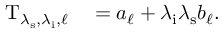<formula> <loc_0><loc_0><loc_500><loc_500>\begin{array} { r l } { T _ { \lambda _ { s } , \lambda _ { i } , \ell } } & = a _ { \ell } + \lambda _ { i } \lambda _ { s } b _ { \ell } . } \end{array}</formula> 